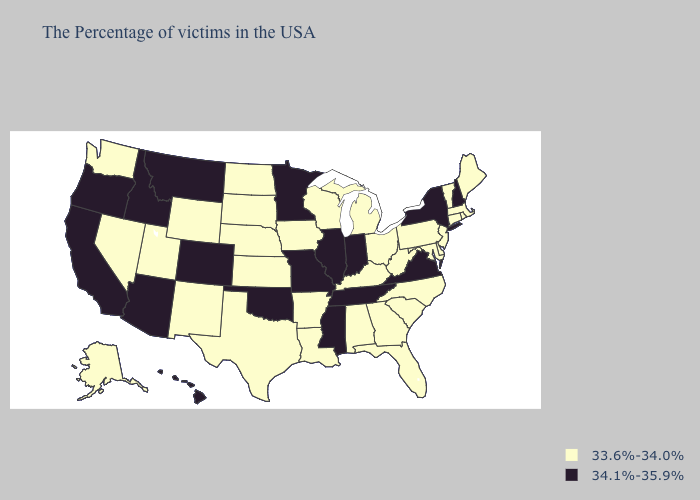Does Tennessee have the highest value in the USA?
Quick response, please. Yes. What is the lowest value in the South?
Give a very brief answer. 33.6%-34.0%. What is the value of West Virginia?
Concise answer only. 33.6%-34.0%. What is the lowest value in the Northeast?
Concise answer only. 33.6%-34.0%. What is the value of Wisconsin?
Short answer required. 33.6%-34.0%. Name the states that have a value in the range 33.6%-34.0%?
Give a very brief answer. Maine, Massachusetts, Rhode Island, Vermont, Connecticut, New Jersey, Delaware, Maryland, Pennsylvania, North Carolina, South Carolina, West Virginia, Ohio, Florida, Georgia, Michigan, Kentucky, Alabama, Wisconsin, Louisiana, Arkansas, Iowa, Kansas, Nebraska, Texas, South Dakota, North Dakota, Wyoming, New Mexico, Utah, Nevada, Washington, Alaska. How many symbols are there in the legend?
Give a very brief answer. 2. Name the states that have a value in the range 34.1%-35.9%?
Quick response, please. New Hampshire, New York, Virginia, Indiana, Tennessee, Illinois, Mississippi, Missouri, Minnesota, Oklahoma, Colorado, Montana, Arizona, Idaho, California, Oregon, Hawaii. Does Colorado have the lowest value in the USA?
Be succinct. No. Does Arkansas have a lower value than Arizona?
Answer briefly. Yes. What is the lowest value in states that border Nevada?
Keep it brief. 33.6%-34.0%. What is the highest value in states that border Louisiana?
Be succinct. 34.1%-35.9%. Name the states that have a value in the range 34.1%-35.9%?
Give a very brief answer. New Hampshire, New York, Virginia, Indiana, Tennessee, Illinois, Mississippi, Missouri, Minnesota, Oklahoma, Colorado, Montana, Arizona, Idaho, California, Oregon, Hawaii. Name the states that have a value in the range 33.6%-34.0%?
Answer briefly. Maine, Massachusetts, Rhode Island, Vermont, Connecticut, New Jersey, Delaware, Maryland, Pennsylvania, North Carolina, South Carolina, West Virginia, Ohio, Florida, Georgia, Michigan, Kentucky, Alabama, Wisconsin, Louisiana, Arkansas, Iowa, Kansas, Nebraska, Texas, South Dakota, North Dakota, Wyoming, New Mexico, Utah, Nevada, Washington, Alaska. 